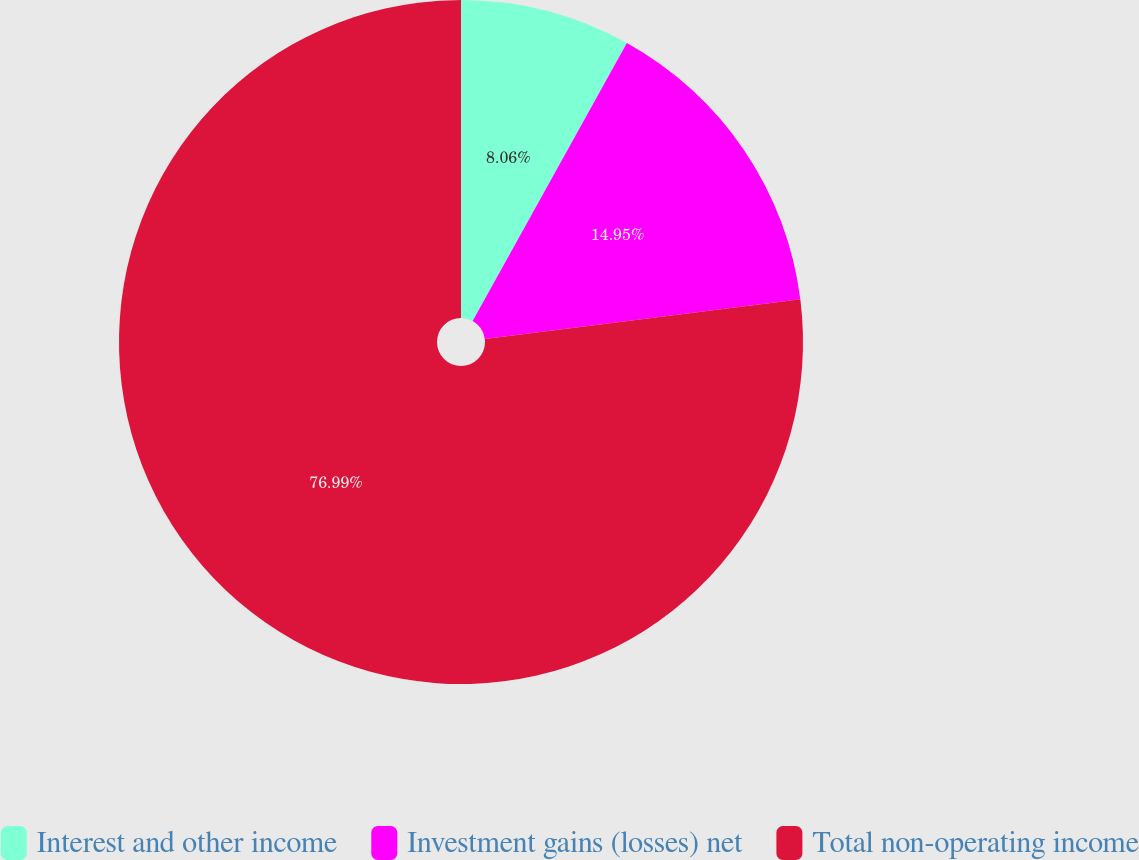<chart> <loc_0><loc_0><loc_500><loc_500><pie_chart><fcel>Interest and other income<fcel>Investment gains (losses) net<fcel>Total non-operating income<nl><fcel>8.06%<fcel>14.95%<fcel>76.99%<nl></chart> 